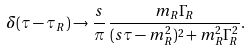<formula> <loc_0><loc_0><loc_500><loc_500>\delta ( \tau - \tau _ { R } ) \to \frac { s } { \pi } \, \frac { m _ { R } \Gamma _ { R } } { ( s \tau - m _ { R } ^ { 2 } ) ^ { 2 } + m _ { R } ^ { 2 } \Gamma _ { R } ^ { 2 } } .</formula> 